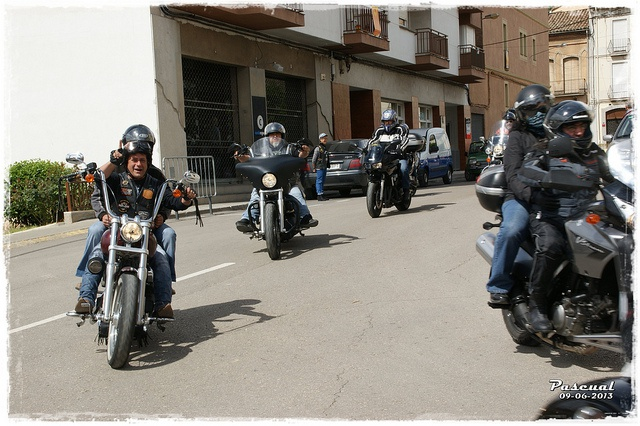Describe the objects in this image and their specific colors. I can see motorcycle in white, black, gray, and darkgray tones, people in white, black, gray, and darkblue tones, motorcycle in white, black, gray, darkgray, and lightgray tones, people in white, black, gray, maroon, and darkgray tones, and people in white, black, and gray tones in this image. 